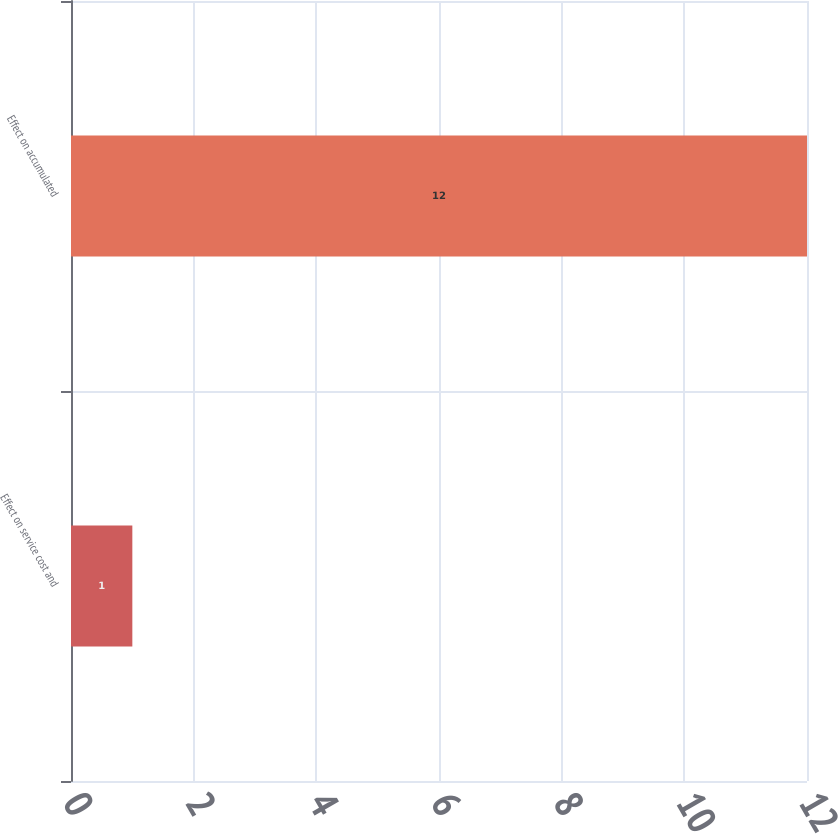Convert chart. <chart><loc_0><loc_0><loc_500><loc_500><bar_chart><fcel>Effect on service cost and<fcel>Effect on accumulated<nl><fcel>1<fcel>12<nl></chart> 